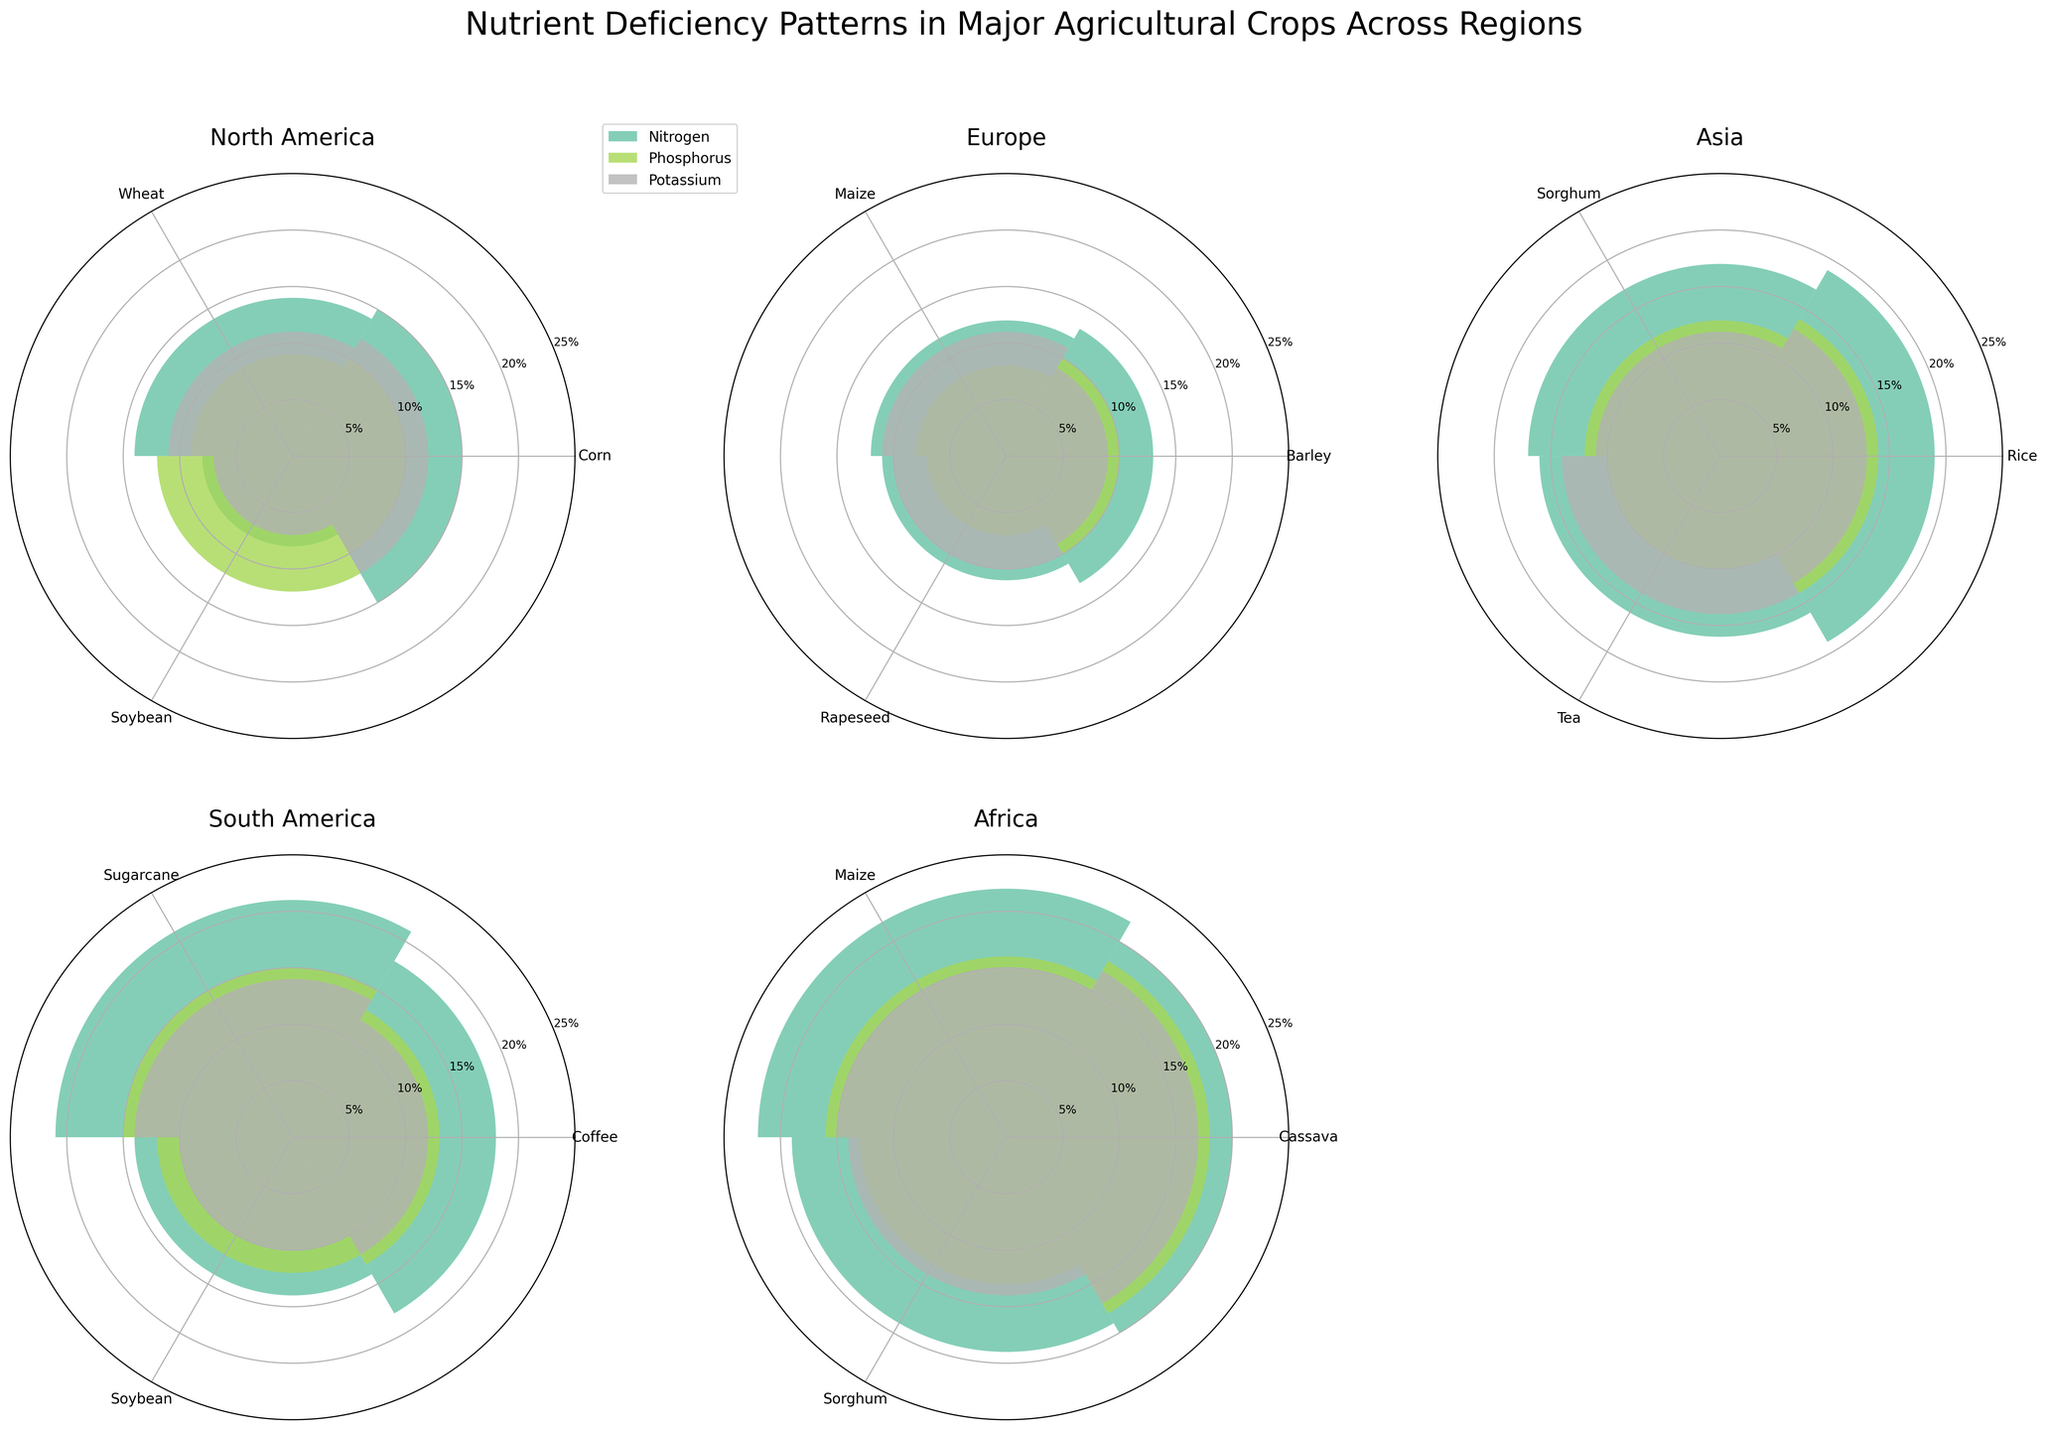what is the highest nitrogen deficiency percentage in Asia? Look at the polar plot for Asia and find the longest bar for Nitrogen. The highest percentage value shown is 19%.
Answer: 19% What crops show a potassium deficiency in Asia? Look at the polar plot for Asia and locate all the bars labeled Potassium. The crops shown with potassium deficiency are Rice, Sorghum, and Tea.
Answer: Rice, Sorghum, Tea Which region has the highest nitrogen deficiency for Maize? Compare the nitrogen deficiency bars labeled as Maize across different regional polar plots. Africa shows the highest percentage at 22%.
Answer: Africa In which region is the nitrogen deficiency percentage for Soybean the lowest, and what is it? Look at the nitrogen bars labeled Soybean across regional plots and check for the smallest length. North America has the lowest percentage at 8%.
Answer: North America, 8% What is the average phosphorus deficiency percentage in South America? Identify the phosphorus deficiency bars for all crops in South America (Coffee, Sugarcane, Soybean). Their deficiencies are 13%, 15%, and 12%, respectively. Sum them (13 + 15 + 12 = 40) and divide by the number of crops (3). The average is 40 / 3 = 13.33%.
Answer: 13.33% Which region shows a higher overall percentage of potassium deficiency: North America or Asia? Sum up the potassium deficiency percentages for all crops in North America (12% + 11% + 7% = 30%) and Asia (13% + 11% + 14% = 38%). Compare the totals. Asia has a higher overall percentage.
Answer: Asia Between Sorghum in Asia and Maize in Europe, which one has a higher phosphorous deficiency? Compare the phosphorus deficiency bars for Sorghum in Asia (12%) and Maize in Europe (8%). The Sorghum in Asia has a higher percentage.
Answer: Sorghum in Asia Which crop in Africa shows the highest overall nutrient deficiency? Look at all nutrient deficiency bars for crops in Africa and identify the crop with the highest longest bar. Cassava shows deficiencies of 20%, 18%, and 17%, the 20% being the highest.
Answer: Cassava What is the difference between the nitrogen deficiency percentage for Soybean in North America and South America? Look at the nitrogen deficiency bars for Soybean in North America and South America. The deficiencies are 8% and 14%, respectively. The difference is 14% - 8% = 6%.
Answer: 6% Which region shows the highest phosphorus deficiency percentage for any crop? Identify the highest phosphorus bar across all regional plots. The highest percentage is in Africa for Cassava with 18%.
Answer: Africa 